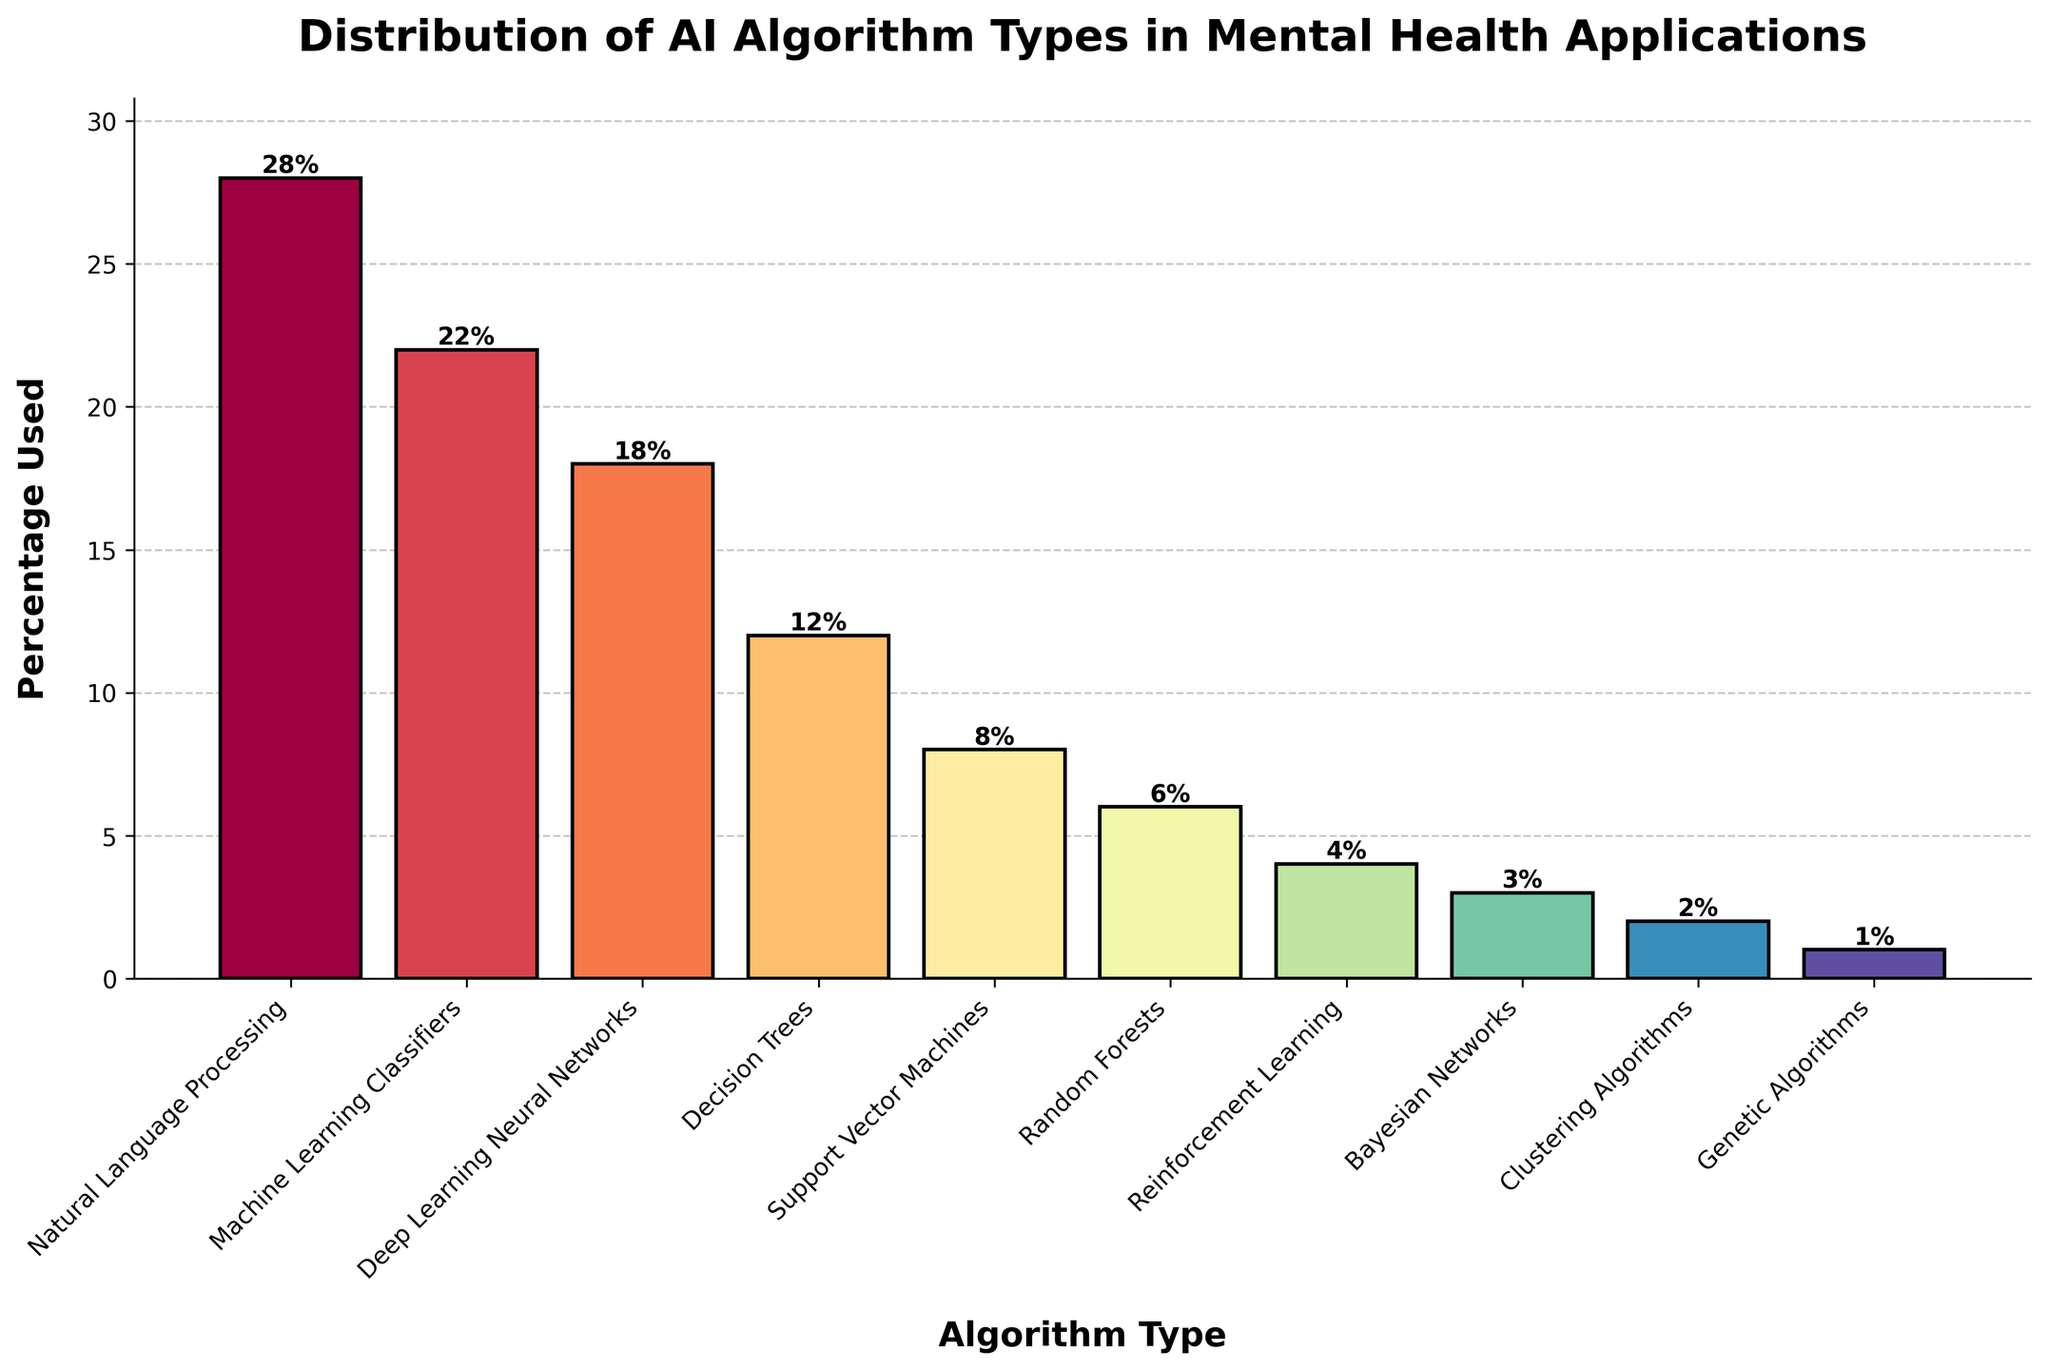What is the most widely used AI algorithm type in mental health applications? The algorithm with the highest percentage is the most widely used. From the figure, Natural Language Processing has the highest percentage at 28%.
Answer: Natural Language Processing What is the total percentage of Machine Learning Classifiers and Deep Learning Neural Networks combined? Sum up the percentages for Machine Learning Classifiers and Deep Learning Neural Networks. Machine Learning Classifiers contribute 22% and Deep Learning Neural Networks contribute 18%. Therefore, their combined total is 22% + 18% = 40%.
Answer: 40% Which algorithm type has the lowest usage percentage, and what is that percentage? Identify the algorithm type with the smallest bar. Genetic Algorithms have the lowest percentage at 1%.
Answer: Genetic Algorithms, 1% How does the usage of Decision Trees compare with Reinforcement Learning? Compare the bars representing Decision Trees and Reinforcement Learning. Decision Trees are higher with 12%, while Reinforcement Learning is 4%. Since 12% is greater than 4%, Decision Trees have higher usage.
Answer: Decision Trees are used more What is the difference in usage percentage between Natural Language Processing and Random Forests? Subtract the percentage of Random Forests from the percentage of Natural Language Processing. Natural Language Processing is 28% and Random Forests is 6%; the difference is 28% - 6% = 22%.
Answer: 22% Which algorithm types have a usage percentage of 10% or more? Identify all bars with heights equal to or above the 10% mark. Natural Language Processing (28%), Machine Learning Classifiers (22%), Deep Learning Neural Networks (18%), and Decision Trees (12%) all meet this criterion.
Answer: Natural Language Processing, Machine Learning Classifiers, Deep Learning Neural Networks, Decision Trees Calculate the average percentage usage of Support Vector Machines and Bayesian Networks. Add the percentages of Support Vector Machines and Bayesian Networks and then divide by the number of algorithms. Support Vector Machines are 8% and Bayesian Networks are 3%. So, (8% + 3%) / 2 = 5.5%.
Answer: 5.5% If Deep Learning Neural Networks usage increases by 4%, will they surpass Machine Learning Classifiers? Add 4% to the current percentage of Deep Learning Neural Networks and compare with Machine Learning Classifiers. Deep Learning Neural Networks currently at 18% would become 22%. Machine Learning Classifiers are already at 22%. Since 22% equals 22%, Deep Learning Neural Networks will equal Machine Learning Classifiers.
Answer: They will equal Machine Learning Classifiers What is the combined percentage usage of all algorithms used less than 10%? Identify all algorithm types with usage percentages below 10% and sum them up. Support Vector Machines (8%), Random Forests (6%), Reinforcement Learning (4%), Bayesian Networks (3%), Clustering Algorithms (2%), Genetic Algorithms (1%), total: 8% + 6% + 4% + 3% + 2% + 1% = 24%.
Answer: 24% Is the usage percentage of Clustering Algorithms higher than that of Reinforcement Learning? Compare the heights of the bars for Clustering Algorithms and Reinforcement Learning. Clustering Algorithms have a percentage usage of 2%, while Reinforcement Learning has 4%. Since 2% is less than 4%, Clustering Algorithms have a lower usage percentage.
Answer: No, it's lower 